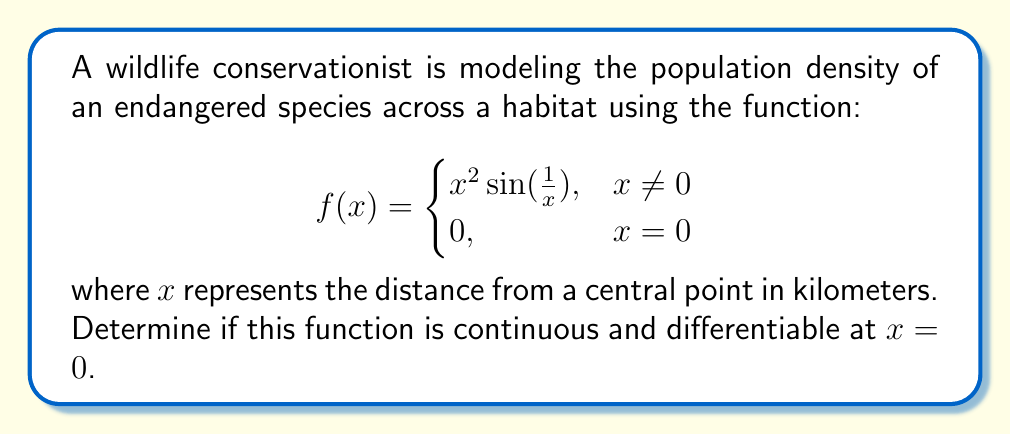Can you answer this question? To determine if the function is continuous and differentiable at $x = 0$, we need to check the following:

1. Continuity at $x = 0$:
   To be continuous at $x = 0$, we need to verify that $\lim_{x \to 0} f(x) = f(0)$.

   Let's evaluate the limit:
   $$\lim_{x \to 0} x^2 \sin(\frac{1}{x}) = \lim_{x \to 0} x^2 \cdot \lim_{x \to 0} \sin(\frac{1}{x})$$

   We know that $\lim_{x \to 0} x^2 = 0$, and $|\sin(\frac{1}{x})| \leq 1$ for all $x \neq 0$.
   
   By the squeeze theorem:
   $$-|x^2| \leq x^2 \sin(\frac{1}{x}) \leq |x^2|$$
   
   As $x \to 0$, both $-|x^2|$ and $|x^2|$ approach 0, so:
   $$\lim_{x \to 0} x^2 \sin(\frac{1}{x}) = 0$$

   Since $\lim_{x \to 0} f(x) = 0 = f(0)$, the function is continuous at $x = 0$.

2. Differentiability at $x = 0$:
   To be differentiable at $x = 0$, the following limit must exist:
   $$\lim_{h \to 0} \frac{f(h) - f(0)}{h} = \lim_{h \to 0} \frac{h^2 \sin(\frac{1}{h}) - 0}{h} = \lim_{h \to 0} h \sin(\frac{1}{h})$$

   Let's consider $g(h) = h \sin(\frac{1}{h})$. We can show that:
   $$\lim_{h \to 0^+} g(h) = 0 \text{ and } \lim_{h \to 0^-} g(h) = 0$$

   However, $g(h)$ oscillates infinitely as $h \to 0$, so the limit does not exist.

   Therefore, the function is not differentiable at $x = 0$.
Answer: The function is continuous at $x = 0$ but not differentiable at $x = 0$. 